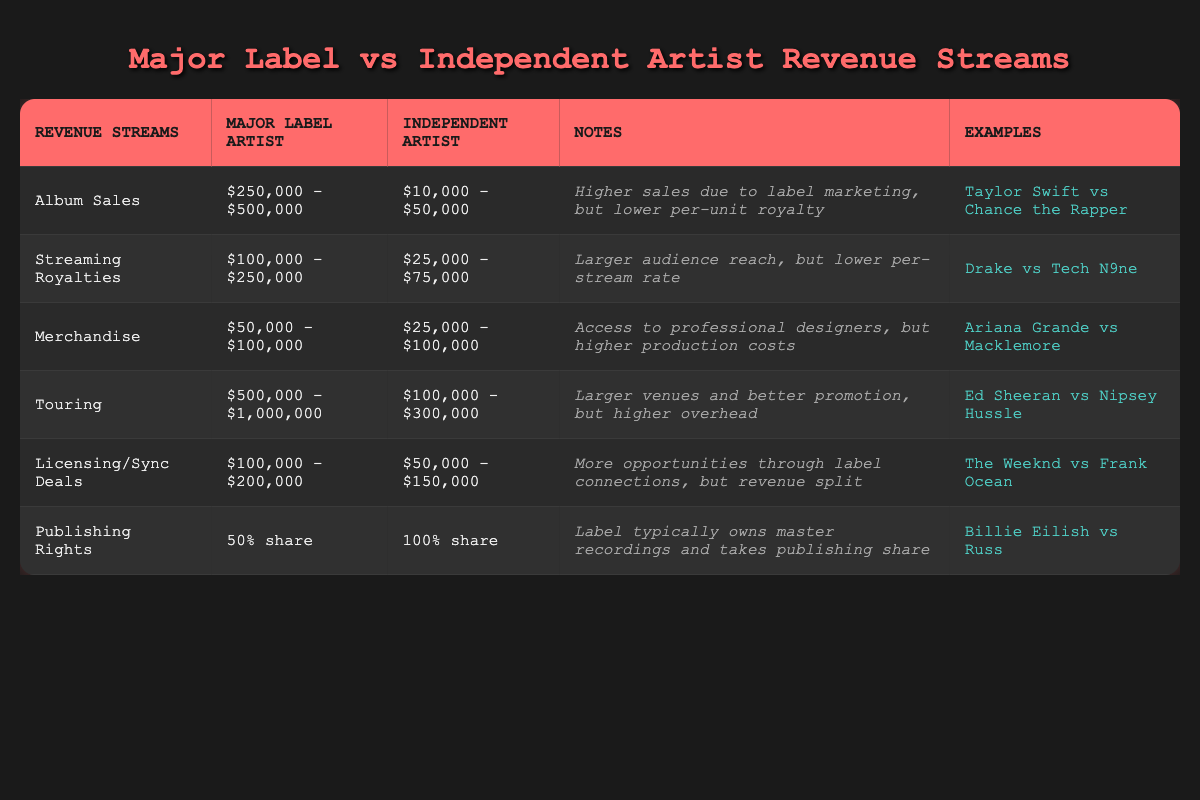What are the album sales for a major label artist? The table lists album sales for a major label artist as "$250,000 - $500,000." This is found directly under the "Major Label Artist" column for the "Album Sales" row.
Answer: $250,000 - $500,000 How much more can a major label artist earn from touring compared to an independent artist? The major label artist's touring revenue is "$500,000 - $1,000,000," while the independent artist's is "$100,000 - $300,000." To find the difference, subtract the maximum of the independent artist revenue from the maximum of the major label revenue: $1,000,000 - $300,000 = $700,000. For the minimum, it is $500,000 - $100,000 = $400,000. Therefore, the difference ranges from $400,000 to $700,000.
Answer: $400,000 to $700,000 Is it true that independent artists keep 100% of their publishing rights? The table shows that independent artists have a "100% share" of publishing rights, while major label artists only have a "50% share." Since the table confirms these details, the statement is true.
Answer: Yes What is the total potential revenue from streaming royalties for a major label artist compared to an independent artist? The major label artist's streaming royalties range from "$100,000 - $250,000" and the independent artist's range from "$25,000 - $75,000." To find the total potential revenue range, we consider both ranges separately. For a major label artist, the total is $250,000 - $100,000 and for an independent artist, it is $75,000 - $25,000. Thus, the total is "$250,000 - $100,000" (major) and "$75,000 - $25,000" (independent) respectively.
Answer: Major: $100,000 - $250,000; Independent: $25,000 - $75,000 Which revenue stream shows the biggest difference between major label and independent artists? To find the revenue stream with the biggest difference, we can analyze all streams. Touring shows a difference of up to $700,000, while album sales show a maximum difference of $450,000 ($500,000 - $50,000). After checking each revenue stream, touring has the largest difference of $700,000.
Answer: Touring has the biggest difference 